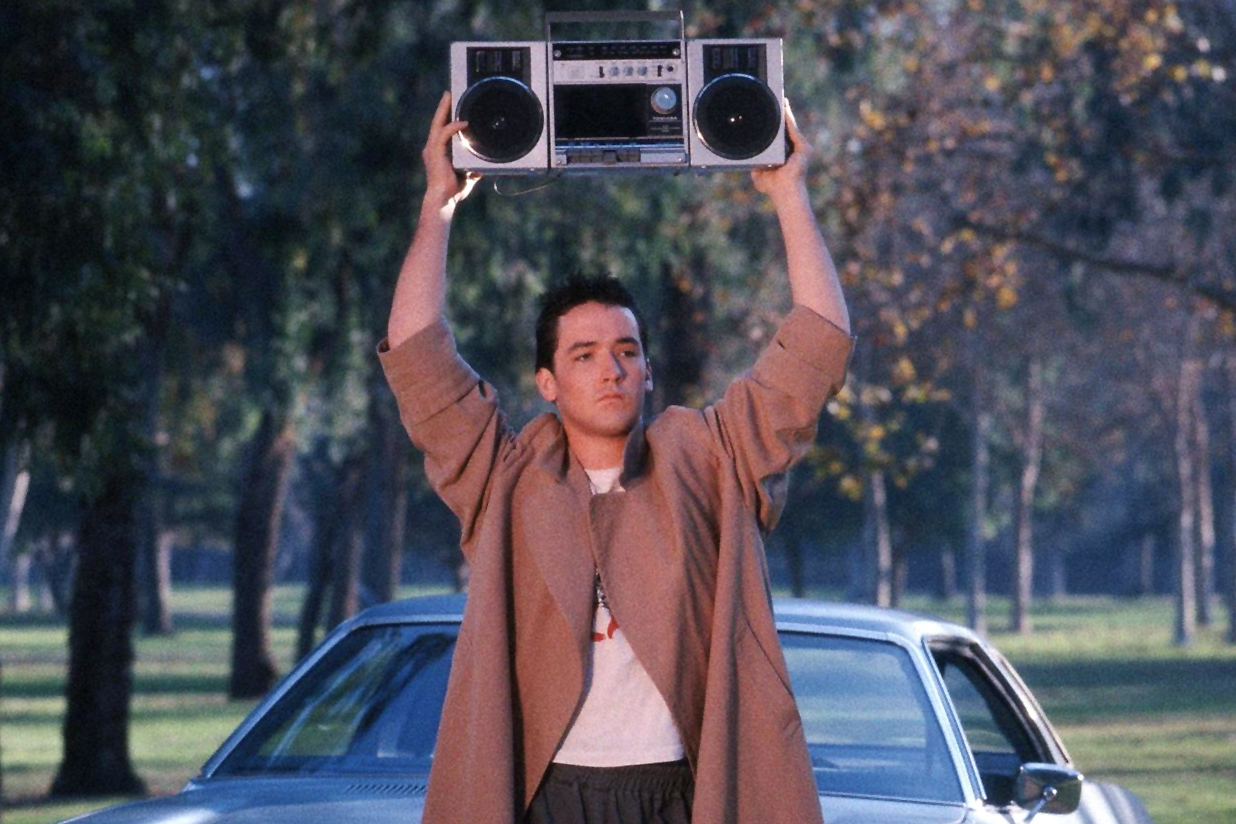Analyze the image in a comprehensive and detailed manner. In this image, we witness a captivating scene from the iconic 1989 film "Say Anything..." featuring the character Lloyd Dobler, portrayed by actor John Cusack. This memorable moment highlights Dobler's grand romantic gesture as he stands outdoors in a determined and resolute stance, holding a large black boombox with silver speakers high above his head. The boombox, a symbol of his unyielding love and defiance, plays a significant role in the film. Dressed in a long beige trench coat over a simple white t-shirt and dark pants, Dobler's casual yet distinctive outfit adds to the scene's impact. The backdrop of a car and trees suggests a serene suburban setting, creating a stark contrast to the intensity of his emotions. The scene captures the essence of how music and love can bridge gaps and connect hearts, making it a timeless representation of youthful passion and determination. 